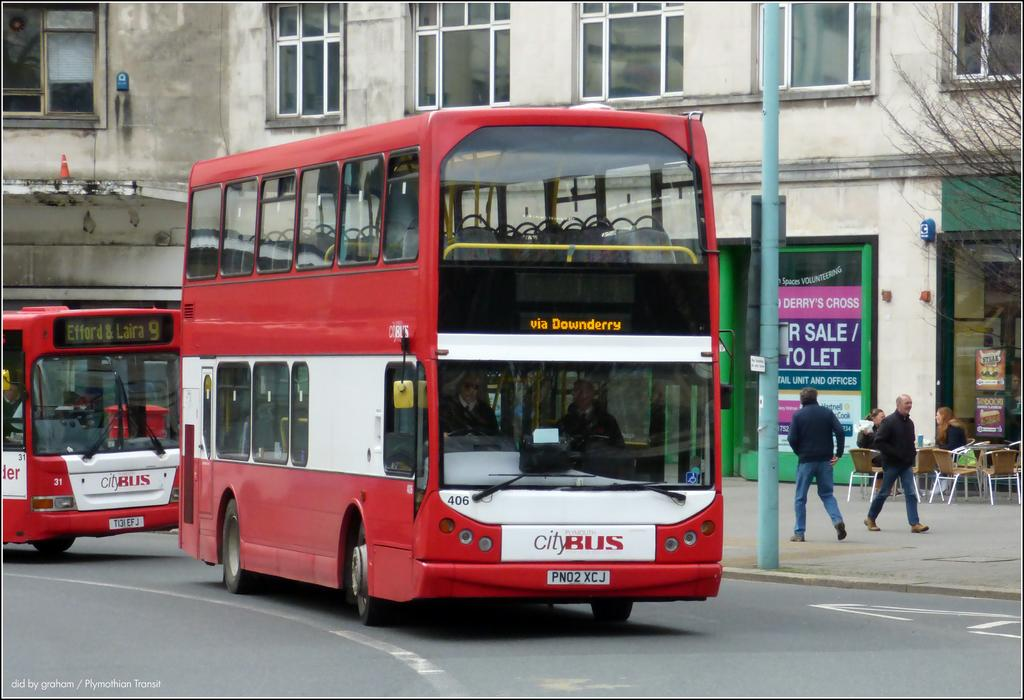<image>
Present a compact description of the photo's key features. The city funded bus travels down the street. 